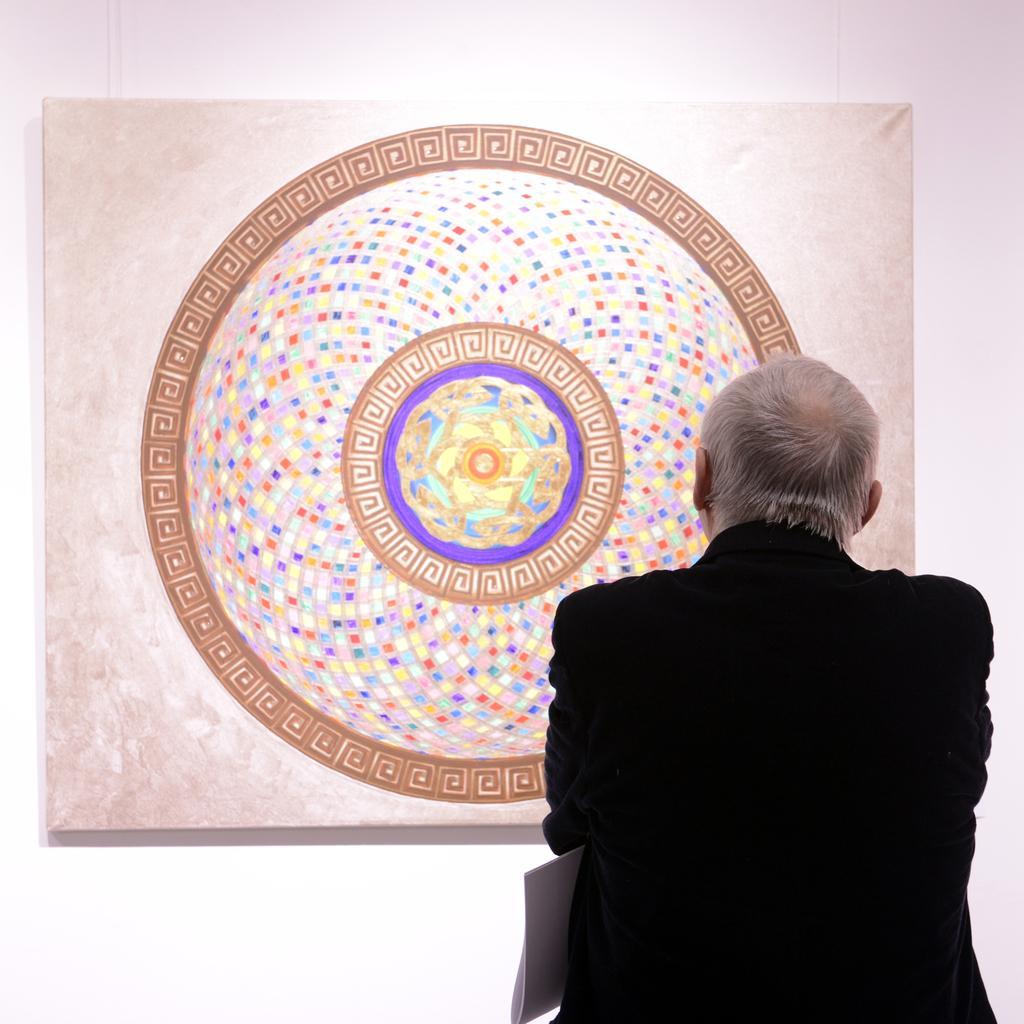Describe this image in one or two sentences. In this image, I can see a person and there is a board attached to the wall. 